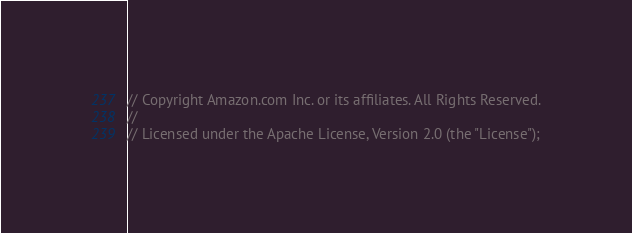<code> <loc_0><loc_0><loc_500><loc_500><_Go_>// Copyright Amazon.com Inc. or its affiliates. All Rights Reserved.
//
// Licensed under the Apache License, Version 2.0 (the "License");</code> 